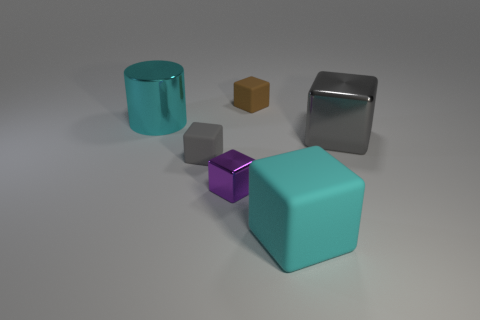The shiny cylinder is what color?
Your answer should be compact. Cyan. How many other things are the same size as the gray matte object?
Give a very brief answer. 2. There is a tiny gray thing that is the same shape as the big cyan rubber thing; what is its material?
Provide a short and direct response. Rubber. What material is the large cyan object behind the gray cube to the left of the matte block that is to the right of the brown matte thing?
Your answer should be compact. Metal. There is a cylinder that is made of the same material as the purple cube; what is its size?
Your response must be concise. Large. Is there any other thing of the same color as the big shiny block?
Offer a terse response. Yes. There is a matte cube that is in front of the small metallic cube; is it the same color as the matte object that is behind the large cyan shiny object?
Give a very brief answer. No. There is a large thing on the right side of the large cyan rubber block; what color is it?
Offer a terse response. Gray. There is a metal block that is left of the gray metal block; is it the same size as the large cyan shiny thing?
Provide a succinct answer. No. Are there fewer large cyan matte blocks than green rubber spheres?
Your answer should be very brief. No. 